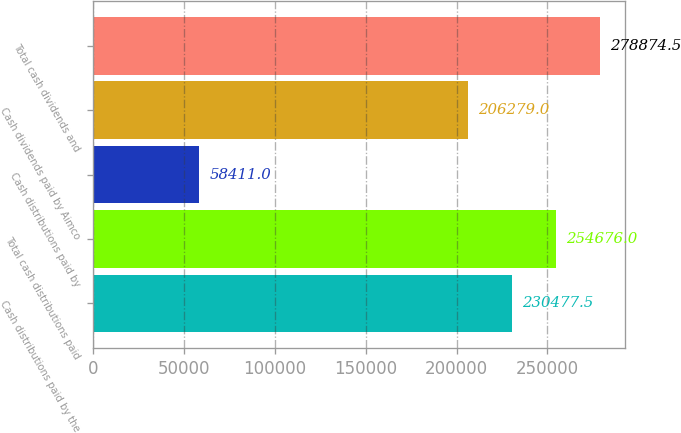<chart> <loc_0><loc_0><loc_500><loc_500><bar_chart><fcel>Cash distributions paid by the<fcel>Total cash distributions paid<fcel>Cash distributions paid by<fcel>Cash dividends paid by Aimco<fcel>Total cash dividends and<nl><fcel>230478<fcel>254676<fcel>58411<fcel>206279<fcel>278874<nl></chart> 